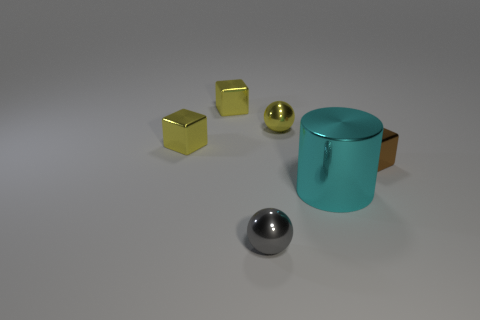There is a small yellow shiny object that is behind the sphere that is to the right of the small gray thing; what shape is it?
Offer a very short reply. Cube. Is there a tiny yellow metallic thing that has the same shape as the small brown object?
Offer a very short reply. Yes. What number of small gray spheres are there?
Your answer should be compact. 1. Is the material of the tiny ball that is right of the gray metal ball the same as the large cyan thing?
Make the answer very short. Yes. Are there any yellow cubes that have the same size as the brown metallic object?
Keep it short and to the point. Yes. Do the small gray metallic thing and the yellow object that is on the right side of the gray ball have the same shape?
Provide a succinct answer. Yes. Are there any yellow shiny things that are right of the tiny object behind the tiny yellow metal object that is right of the gray metallic thing?
Your response must be concise. Yes. How big is the cylinder?
Offer a very short reply. Large. How many other objects are there of the same color as the big object?
Ensure brevity in your answer.  0. There is a metallic thing that is on the right side of the big cyan thing; is it the same shape as the large metallic thing?
Your answer should be very brief. No. 